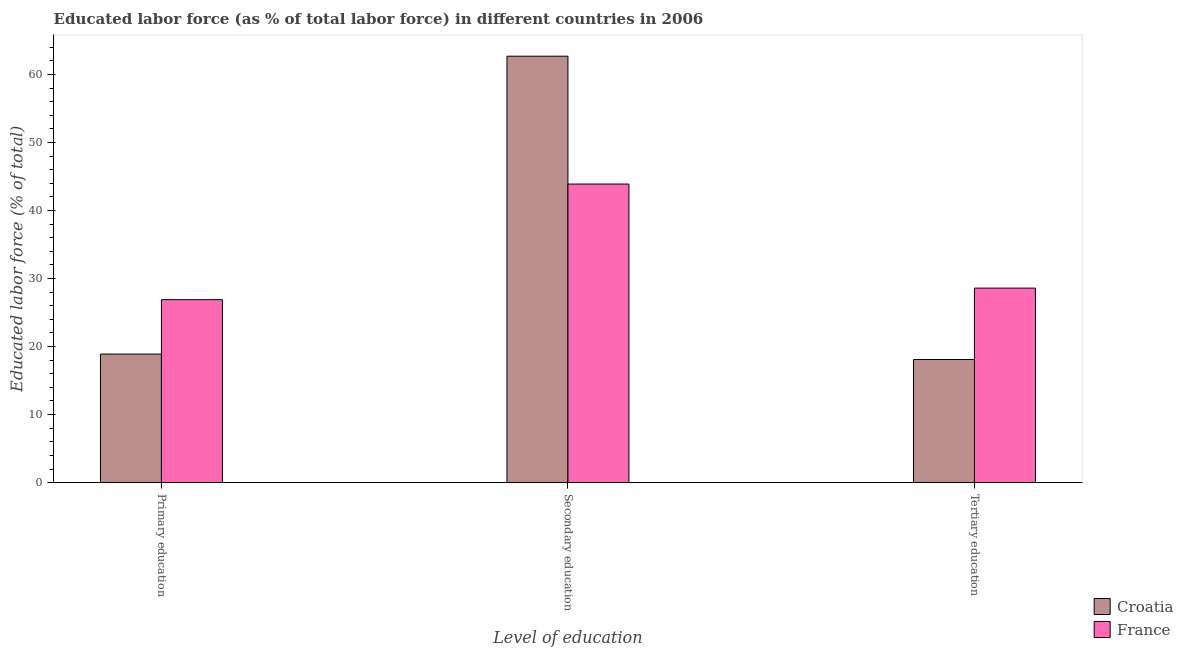How many groups of bars are there?
Make the answer very short. 3. Are the number of bars on each tick of the X-axis equal?
Provide a succinct answer. Yes. How many bars are there on the 1st tick from the left?
Offer a very short reply. 2. What is the label of the 3rd group of bars from the left?
Ensure brevity in your answer.  Tertiary education. What is the percentage of labor force who received tertiary education in France?
Offer a terse response. 28.6. Across all countries, what is the maximum percentage of labor force who received secondary education?
Keep it short and to the point. 62.7. Across all countries, what is the minimum percentage of labor force who received tertiary education?
Make the answer very short. 18.1. In which country was the percentage of labor force who received primary education minimum?
Give a very brief answer. Croatia. What is the total percentage of labor force who received tertiary education in the graph?
Ensure brevity in your answer.  46.7. What is the difference between the percentage of labor force who received tertiary education in France and that in Croatia?
Your answer should be very brief. 10.5. What is the difference between the percentage of labor force who received secondary education in Croatia and the percentage of labor force who received tertiary education in France?
Keep it short and to the point. 34.1. What is the average percentage of labor force who received tertiary education per country?
Provide a succinct answer. 23.35. What is the difference between the percentage of labor force who received tertiary education and percentage of labor force who received secondary education in France?
Your answer should be very brief. -15.3. In how many countries, is the percentage of labor force who received secondary education greater than 36 %?
Offer a very short reply. 2. What is the ratio of the percentage of labor force who received tertiary education in Croatia to that in France?
Your answer should be very brief. 0.63. Is the percentage of labor force who received secondary education in France less than that in Croatia?
Make the answer very short. Yes. What is the difference between the highest and the second highest percentage of labor force who received primary education?
Keep it short and to the point. 8. What is the difference between the highest and the lowest percentage of labor force who received primary education?
Offer a terse response. 8. In how many countries, is the percentage of labor force who received secondary education greater than the average percentage of labor force who received secondary education taken over all countries?
Your response must be concise. 1. Is the sum of the percentage of labor force who received tertiary education in France and Croatia greater than the maximum percentage of labor force who received secondary education across all countries?
Provide a short and direct response. No. What does the 2nd bar from the right in Tertiary education represents?
Offer a terse response. Croatia. Is it the case that in every country, the sum of the percentage of labor force who received primary education and percentage of labor force who received secondary education is greater than the percentage of labor force who received tertiary education?
Make the answer very short. Yes. Are all the bars in the graph horizontal?
Ensure brevity in your answer.  No. Are the values on the major ticks of Y-axis written in scientific E-notation?
Offer a terse response. No. Does the graph contain grids?
Offer a terse response. No. How many legend labels are there?
Make the answer very short. 2. How are the legend labels stacked?
Your answer should be very brief. Vertical. What is the title of the graph?
Your answer should be compact. Educated labor force (as % of total labor force) in different countries in 2006. What is the label or title of the X-axis?
Keep it short and to the point. Level of education. What is the label or title of the Y-axis?
Offer a very short reply. Educated labor force (% of total). What is the Educated labor force (% of total) of Croatia in Primary education?
Your answer should be compact. 18.9. What is the Educated labor force (% of total) in France in Primary education?
Keep it short and to the point. 26.9. What is the Educated labor force (% of total) in Croatia in Secondary education?
Give a very brief answer. 62.7. What is the Educated labor force (% of total) of France in Secondary education?
Your response must be concise. 43.9. What is the Educated labor force (% of total) of Croatia in Tertiary education?
Provide a succinct answer. 18.1. What is the Educated labor force (% of total) in France in Tertiary education?
Provide a short and direct response. 28.6. Across all Level of education, what is the maximum Educated labor force (% of total) of Croatia?
Offer a very short reply. 62.7. Across all Level of education, what is the maximum Educated labor force (% of total) of France?
Your answer should be very brief. 43.9. Across all Level of education, what is the minimum Educated labor force (% of total) in Croatia?
Offer a terse response. 18.1. Across all Level of education, what is the minimum Educated labor force (% of total) of France?
Your answer should be compact. 26.9. What is the total Educated labor force (% of total) in Croatia in the graph?
Ensure brevity in your answer.  99.7. What is the total Educated labor force (% of total) of France in the graph?
Your response must be concise. 99.4. What is the difference between the Educated labor force (% of total) in Croatia in Primary education and that in Secondary education?
Make the answer very short. -43.8. What is the difference between the Educated labor force (% of total) in Croatia in Secondary education and that in Tertiary education?
Provide a short and direct response. 44.6. What is the difference between the Educated labor force (% of total) in France in Secondary education and that in Tertiary education?
Your response must be concise. 15.3. What is the difference between the Educated labor force (% of total) of Croatia in Primary education and the Educated labor force (% of total) of France in Tertiary education?
Provide a short and direct response. -9.7. What is the difference between the Educated labor force (% of total) in Croatia in Secondary education and the Educated labor force (% of total) in France in Tertiary education?
Keep it short and to the point. 34.1. What is the average Educated labor force (% of total) in Croatia per Level of education?
Provide a succinct answer. 33.23. What is the average Educated labor force (% of total) in France per Level of education?
Offer a terse response. 33.13. What is the difference between the Educated labor force (% of total) in Croatia and Educated labor force (% of total) in France in Primary education?
Ensure brevity in your answer.  -8. What is the difference between the Educated labor force (% of total) in Croatia and Educated labor force (% of total) in France in Secondary education?
Keep it short and to the point. 18.8. What is the difference between the Educated labor force (% of total) of Croatia and Educated labor force (% of total) of France in Tertiary education?
Provide a succinct answer. -10.5. What is the ratio of the Educated labor force (% of total) of Croatia in Primary education to that in Secondary education?
Give a very brief answer. 0.3. What is the ratio of the Educated labor force (% of total) of France in Primary education to that in Secondary education?
Make the answer very short. 0.61. What is the ratio of the Educated labor force (% of total) of Croatia in Primary education to that in Tertiary education?
Your answer should be compact. 1.04. What is the ratio of the Educated labor force (% of total) of France in Primary education to that in Tertiary education?
Your answer should be compact. 0.94. What is the ratio of the Educated labor force (% of total) of Croatia in Secondary education to that in Tertiary education?
Offer a terse response. 3.46. What is the ratio of the Educated labor force (% of total) in France in Secondary education to that in Tertiary education?
Ensure brevity in your answer.  1.53. What is the difference between the highest and the second highest Educated labor force (% of total) of Croatia?
Give a very brief answer. 43.8. What is the difference between the highest and the second highest Educated labor force (% of total) in France?
Ensure brevity in your answer.  15.3. What is the difference between the highest and the lowest Educated labor force (% of total) of Croatia?
Keep it short and to the point. 44.6. 